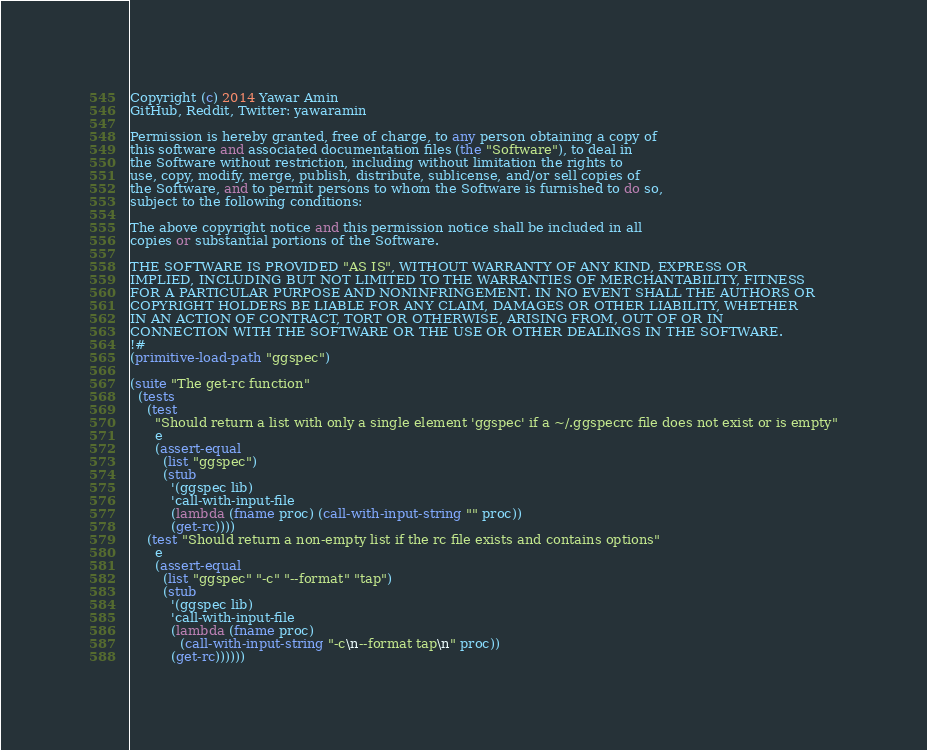<code> <loc_0><loc_0><loc_500><loc_500><_Scheme_>Copyright (c) 2014 Yawar Amin
GitHub, Reddit, Twitter: yawaramin

Permission is hereby granted, free of charge, to any person obtaining a copy of
this software and associated documentation files (the "Software"), to deal in
the Software without restriction, including without limitation the rights to
use, copy, modify, merge, publish, distribute, sublicense, and/or sell copies of
the Software, and to permit persons to whom the Software is furnished to do so,
subject to the following conditions:

The above copyright notice and this permission notice shall be included in all
copies or substantial portions of the Software.

THE SOFTWARE IS PROVIDED "AS IS", WITHOUT WARRANTY OF ANY KIND, EXPRESS OR
IMPLIED, INCLUDING BUT NOT LIMITED TO THE WARRANTIES OF MERCHANTABILITY, FITNESS
FOR A PARTICULAR PURPOSE AND NONINFRINGEMENT. IN NO EVENT SHALL THE AUTHORS OR
COPYRIGHT HOLDERS BE LIABLE FOR ANY CLAIM, DAMAGES OR OTHER LIABILITY, WHETHER
IN AN ACTION OF CONTRACT, TORT OR OTHERWISE, ARISING FROM, OUT OF OR IN
CONNECTION WITH THE SOFTWARE OR THE USE OR OTHER DEALINGS IN THE SOFTWARE.
!#
(primitive-load-path "ggspec")

(suite "The get-rc function"
  (tests
    (test
      "Should return a list with only a single element 'ggspec' if a ~/.ggspecrc file does not exist or is empty"
      e
      (assert-equal
        (list "ggspec")
        (stub
          '(ggspec lib)
          'call-with-input-file
          (lambda (fname proc) (call-with-input-string "" proc))
          (get-rc))))
    (test "Should return a non-empty list if the rc file exists and contains options"
      e
      (assert-equal
        (list "ggspec" "-c" "--format" "tap")
        (stub
          '(ggspec lib)
          'call-with-input-file
          (lambda (fname proc)
            (call-with-input-string "-c\n--format tap\n" proc))
          (get-rc))))))

</code> 